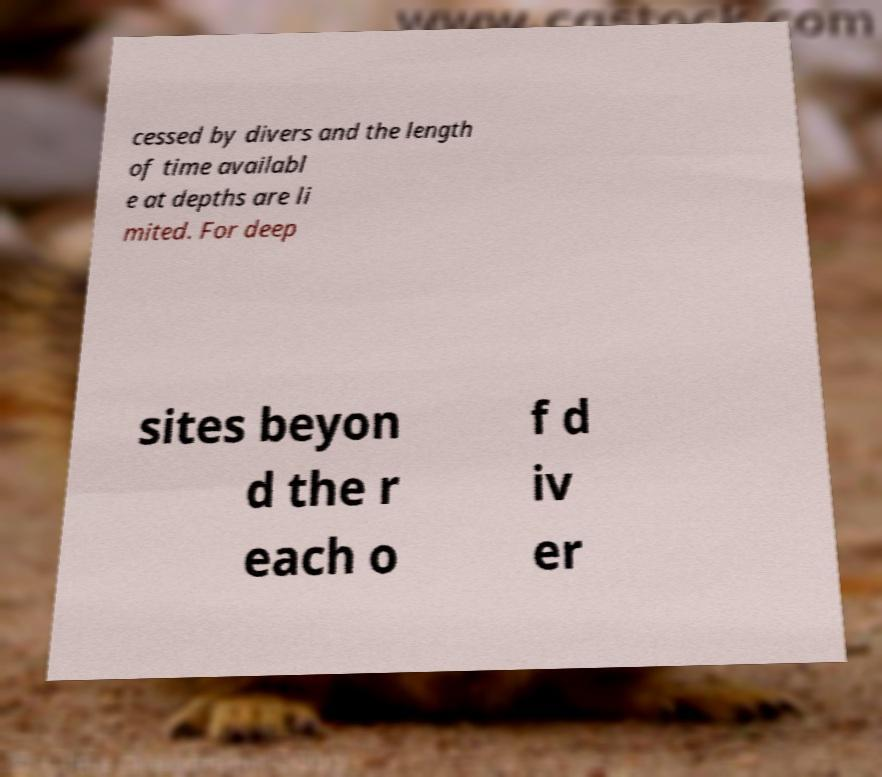What messages or text are displayed in this image? I need them in a readable, typed format. cessed by divers and the length of time availabl e at depths are li mited. For deep sites beyon d the r each o f d iv er 